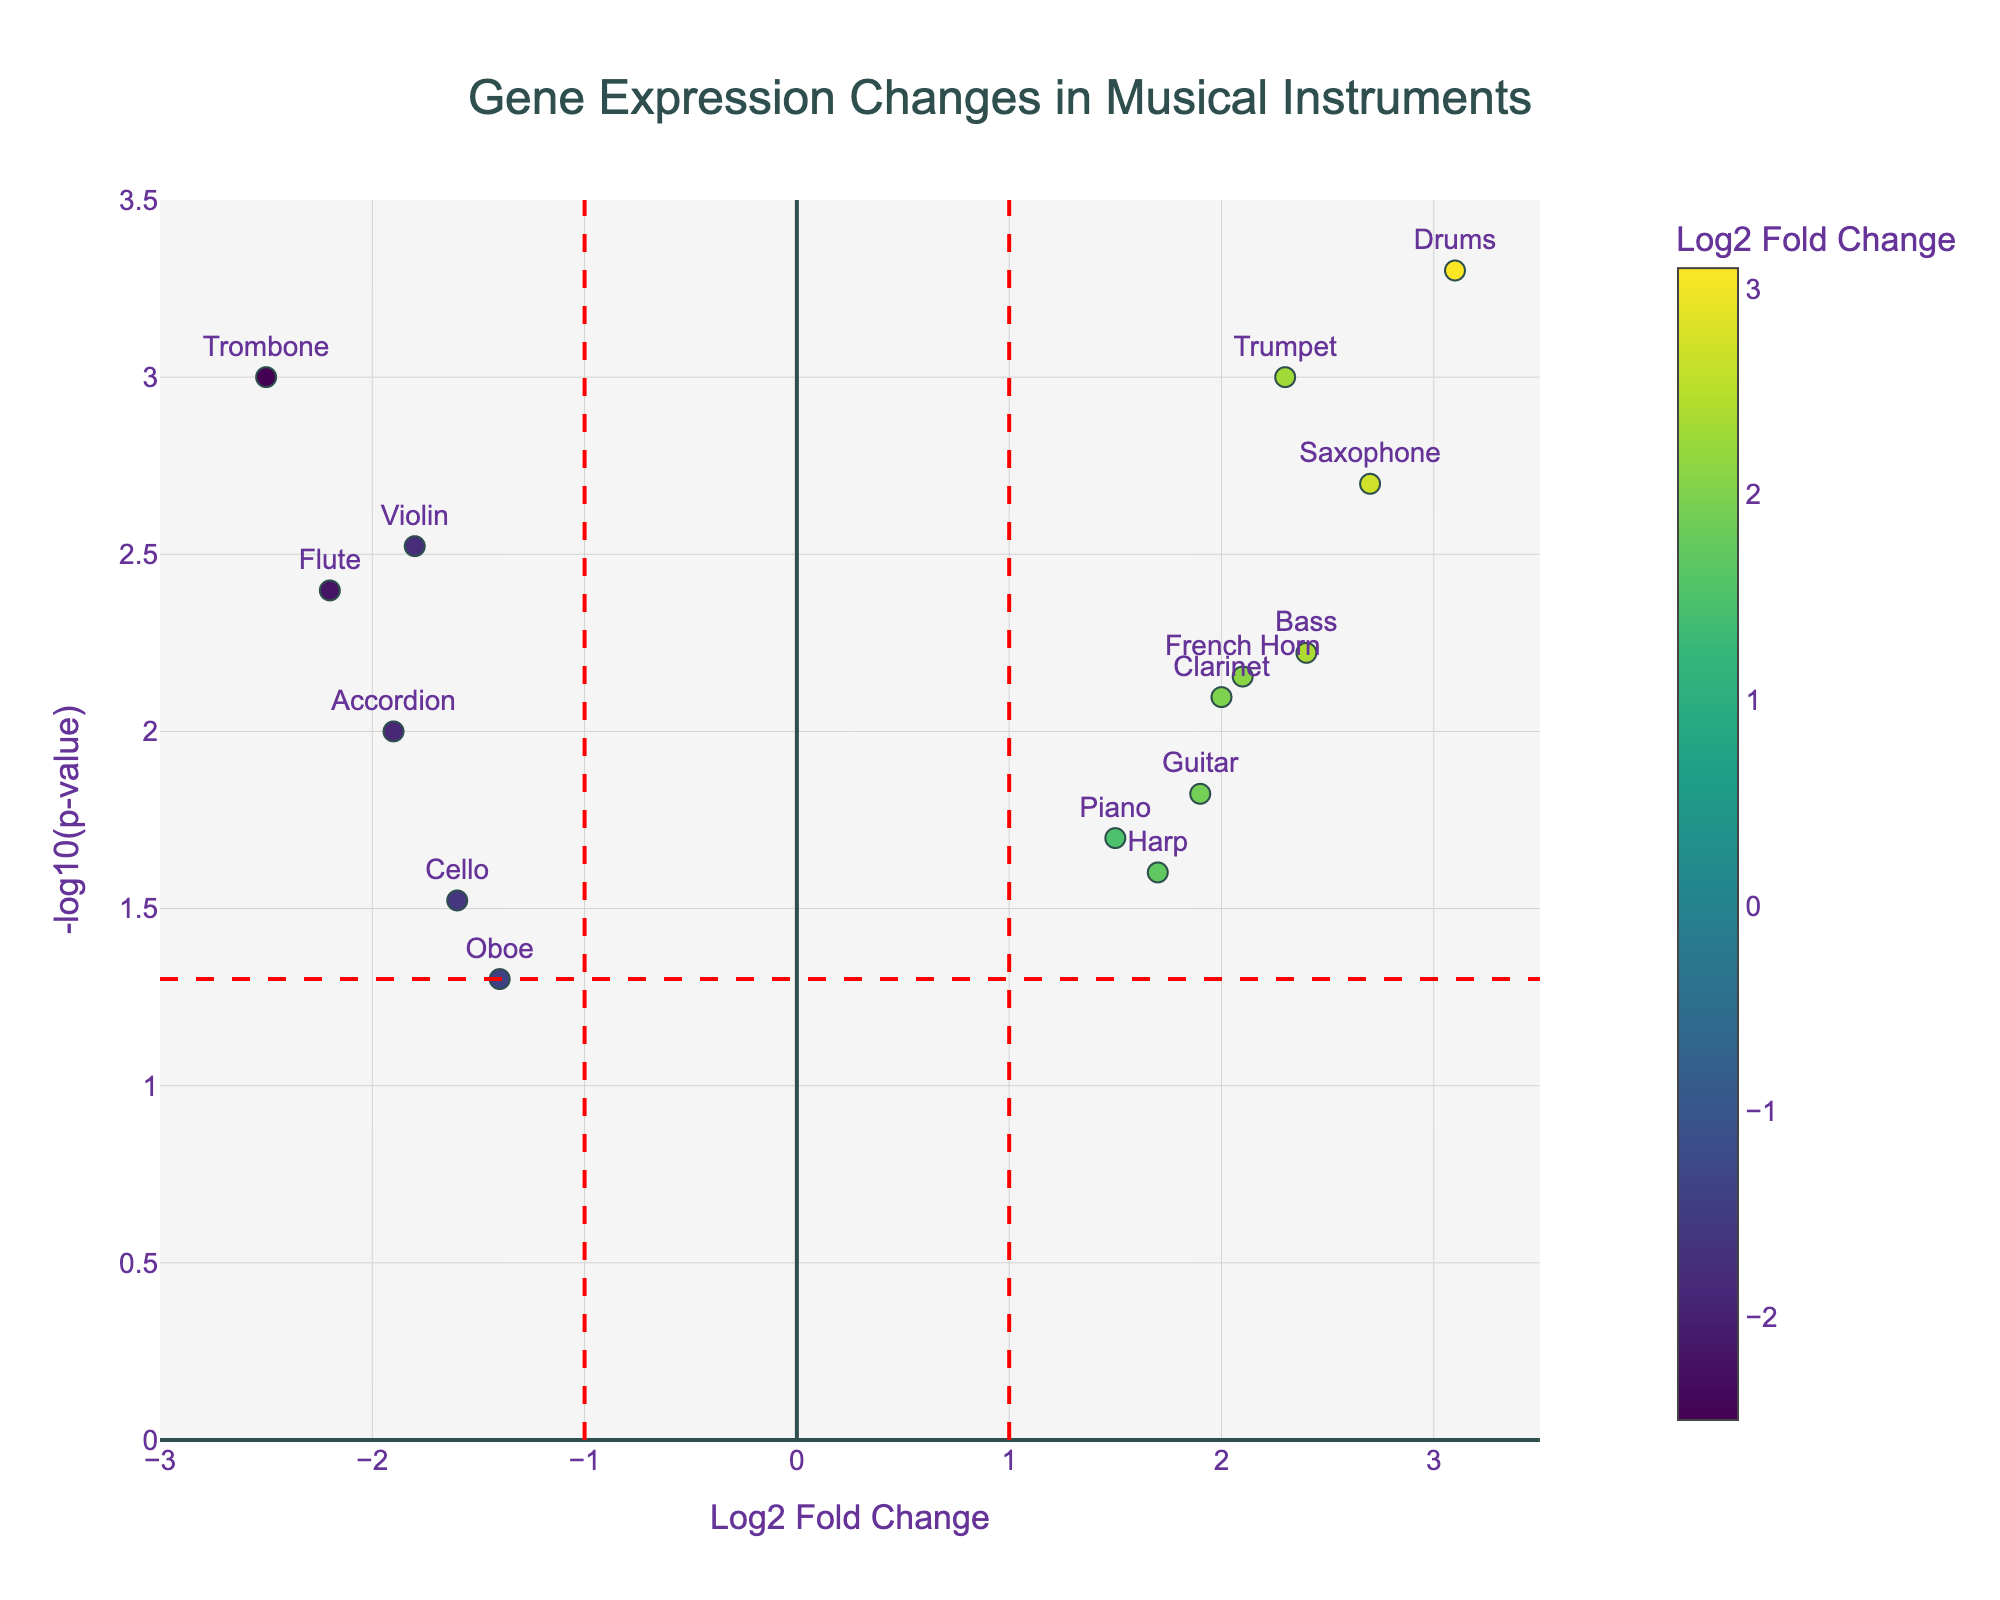What is the title of the plot? The title is displayed at the top center of the plot. It reads "Gene Expression Changes in Musical Instruments."
Answer: Gene Expression Changes in Musical Instruments What does the X-axis represent? The label on the X-axis indicates it represents "Log2 Fold Change," which shows the change in gene expression levels.
Answer: Log2 Fold Change What does the Y-axis represent? The label on the Y-axis indicates it represents "-log10(p-value)," which measures the statistical significance of the gene expression changes.
Answer: -log10(p-value) How many genes have a positive Log2 Fold Change? By observing the data points on the right side of the Y-axis, we can count the genes with positive Log2 Fold Change.
Answer: 9 Which gene associated with a musical instrument has the greatest fold change? The greatest Log2 Fold Change value is the highest point on the X-axis. The gene BDNF_Drums has the highest value of 3.1.
Answer: BDNF_Drums What color represents the highest Log2 Fold Change? The color bar on the right of the plot indicates the color gradient used. The highest Log2 Fold Change is yellow, as shown in the colorscale.
Answer: Yellow How many genes have a statistically significant change (p-value < 0.05)? Genes with statistically significant changes have a -log10(p-value) above approximately 1.3 (-log10(0.05)). We count these data points.
Answer: 12 Which gene associated with a musical instrument has both positive Log2 Fold Change and the most significant p-value? The data point with the highest combination of Log2 Fold Change and -log10(p-value), on the upper right side, is the gene BDNF_Drums.
Answer: BDNF_Drums Compare FOXP2_Trumpet and DRD2_Trombone in terms of fold change and significance. Which is higher in significance? DRD2_Trombone has a -log10(p-value) of 3, higher than FOXP2_Trumpet's 3, indicating DRD2_Trombone is higher in significance.
Answer: DRD2_Trombone Which data point lies closest to the intersection of the fold change thresholds (Log2 Fold Change of ±1)? By looking at the points close to the vertical lines at Log2 Fold Change of ±1, we see GRIN1_Piano is closest to the line at Log2 Fold Change of 1.
Answer: GRIN1_Piano 